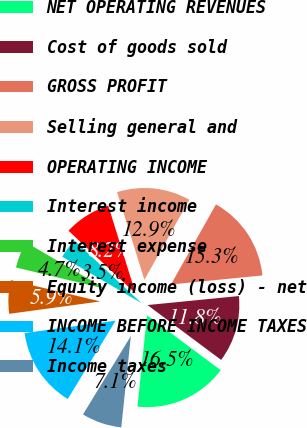<chart> <loc_0><loc_0><loc_500><loc_500><pie_chart><fcel>NET OPERATING REVENUES<fcel>Cost of goods sold<fcel>GROSS PROFIT<fcel>Selling general and<fcel>OPERATING INCOME<fcel>Interest income<fcel>Interest expense<fcel>Equity income (loss) - net<fcel>INCOME BEFORE INCOME TAXES<fcel>Income taxes<nl><fcel>16.47%<fcel>11.76%<fcel>15.29%<fcel>12.94%<fcel>8.24%<fcel>3.53%<fcel>4.71%<fcel>5.88%<fcel>14.12%<fcel>7.06%<nl></chart> 